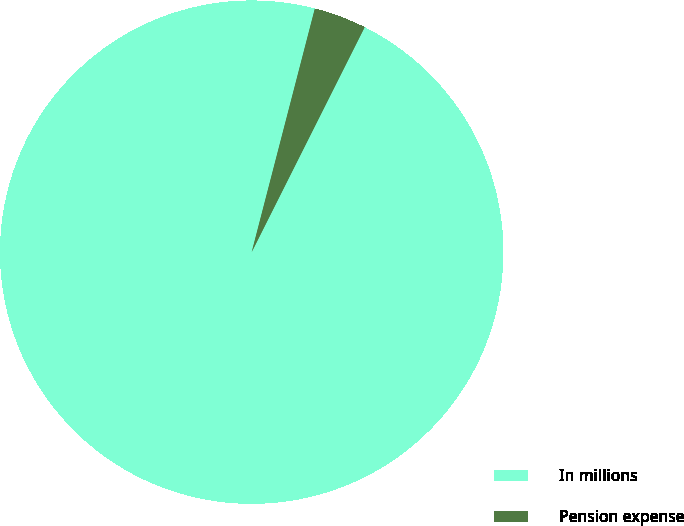<chart> <loc_0><loc_0><loc_500><loc_500><pie_chart><fcel>In millions<fcel>Pension expense<nl><fcel>96.63%<fcel>3.37%<nl></chart> 